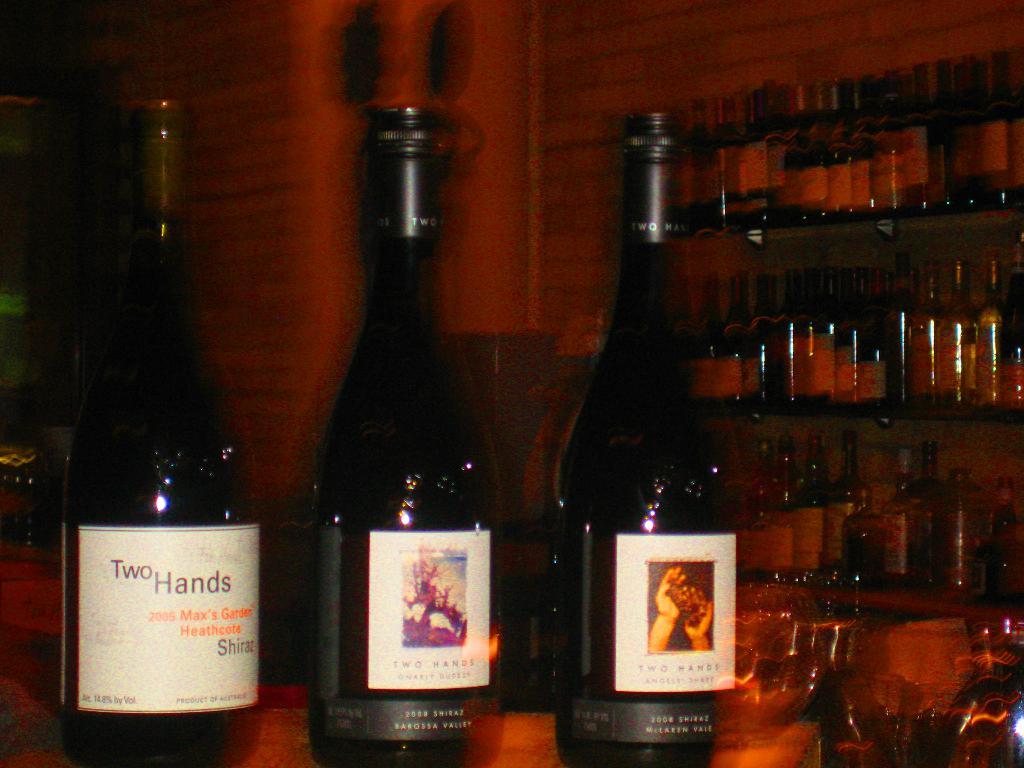What brand are these drinks made by?
Offer a terse response. Two hands. What year is the left-most bottle from?
Offer a very short reply. 2005. 